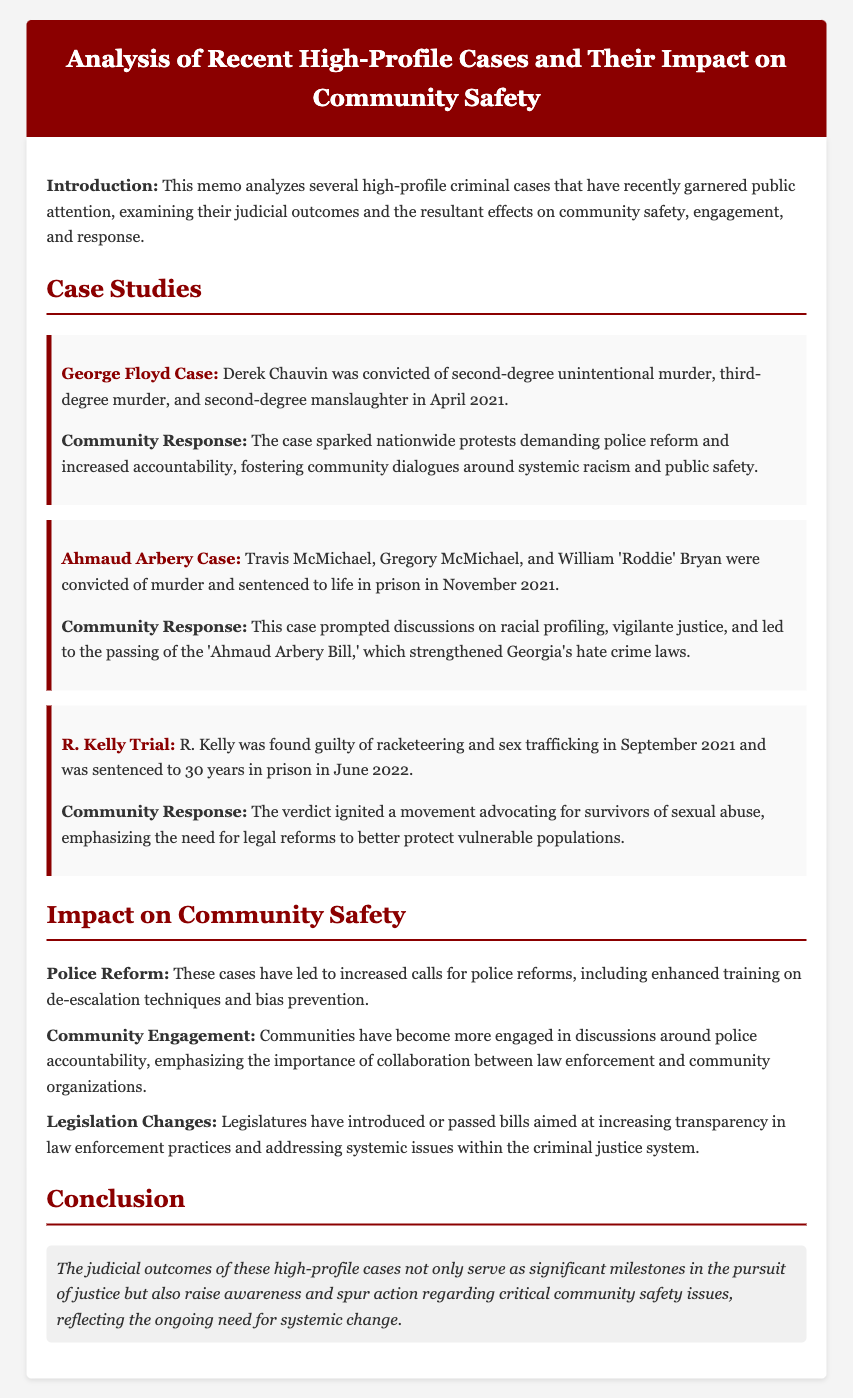What was Derek Chauvin convicted of? Derek Chauvin was convicted of second-degree unintentional murder, third-degree murder, and second-degree manslaughter.
Answer: second-degree unintentional murder, third-degree murder, and second-degree manslaughter When were the convictions in the Ahmaud Arbery case? The convictions in the Ahmaud Arbery case occurred in November 2021.
Answer: November 2021 What legislation was prompted by the Ahmaud Arbery case? The case led to the passing of the 'Ahmaud Arbery Bill,' which strengthened Georgia's hate crime laws.
Answer: 'Ahmaud Arbery Bill' What sentence did R. Kelly receive? R. Kelly was sentenced to 30 years in prison.
Answer: 30 years in prison How have these cases impacted community engagement? The cases have led to increased community engagement in discussions around police accountability.
Answer: increased community engagement What was a significant community response to the George Floyd case? The case sparked nationwide protests demanding police reform and increased accountability.
Answer: nationwide protests demanding police reform What type of reforms have been called for as a result of these cases? Increased calls for police reforms have been made, including enhanced training on de-escalation techniques.
Answer: police reforms What is a key conclusion drawn from the memo? The judicial outcomes serve as significant milestones in the pursuit of justice and raise awareness regarding critical community safety issues.
Answer: significant milestones in the pursuit of justice What specific training is emphasized for police reforms? Enhanced training on de-escalation techniques and bias prevention is emphasized.
Answer: de-escalation techniques and bias prevention 